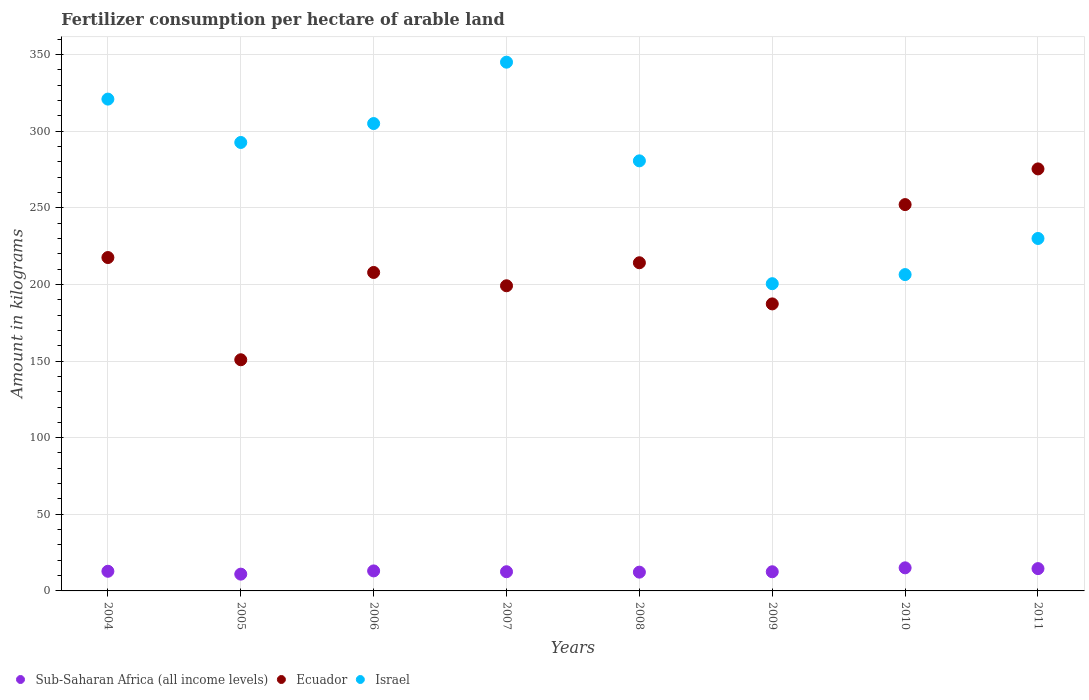How many different coloured dotlines are there?
Offer a very short reply. 3. Is the number of dotlines equal to the number of legend labels?
Provide a short and direct response. Yes. What is the amount of fertilizer consumption in Ecuador in 2004?
Your answer should be compact. 217.53. Across all years, what is the maximum amount of fertilizer consumption in Israel?
Keep it short and to the point. 345. Across all years, what is the minimum amount of fertilizer consumption in Ecuador?
Give a very brief answer. 150.83. In which year was the amount of fertilizer consumption in Ecuador maximum?
Your answer should be very brief. 2011. In which year was the amount of fertilizer consumption in Israel minimum?
Keep it short and to the point. 2009. What is the total amount of fertilizer consumption in Ecuador in the graph?
Your answer should be compact. 1704.08. What is the difference between the amount of fertilizer consumption in Israel in 2004 and that in 2008?
Keep it short and to the point. 40.29. What is the difference between the amount of fertilizer consumption in Sub-Saharan Africa (all income levels) in 2006 and the amount of fertilizer consumption in Ecuador in 2004?
Provide a short and direct response. -204.47. What is the average amount of fertilizer consumption in Sub-Saharan Africa (all income levels) per year?
Your answer should be very brief. 12.97. In the year 2008, what is the difference between the amount of fertilizer consumption in Ecuador and amount of fertilizer consumption in Sub-Saharan Africa (all income levels)?
Give a very brief answer. 201.87. What is the ratio of the amount of fertilizer consumption in Sub-Saharan Africa (all income levels) in 2006 to that in 2011?
Your answer should be compact. 0.9. What is the difference between the highest and the second highest amount of fertilizer consumption in Israel?
Make the answer very short. 24.1. What is the difference between the highest and the lowest amount of fertilizer consumption in Sub-Saharan Africa (all income levels)?
Provide a short and direct response. 4.11. In how many years, is the amount of fertilizer consumption in Ecuador greater than the average amount of fertilizer consumption in Ecuador taken over all years?
Provide a short and direct response. 4. Is the sum of the amount of fertilizer consumption in Ecuador in 2005 and 2006 greater than the maximum amount of fertilizer consumption in Sub-Saharan Africa (all income levels) across all years?
Give a very brief answer. Yes. Is the amount of fertilizer consumption in Ecuador strictly greater than the amount of fertilizer consumption in Israel over the years?
Provide a succinct answer. No. How many years are there in the graph?
Offer a very short reply. 8. Where does the legend appear in the graph?
Your answer should be compact. Bottom left. What is the title of the graph?
Keep it short and to the point. Fertilizer consumption per hectare of arable land. Does "Turks and Caicos Islands" appear as one of the legend labels in the graph?
Make the answer very short. No. What is the label or title of the X-axis?
Ensure brevity in your answer.  Years. What is the label or title of the Y-axis?
Your response must be concise. Amount in kilograms. What is the Amount in kilograms of Sub-Saharan Africa (all income levels) in 2004?
Ensure brevity in your answer.  12.82. What is the Amount in kilograms of Ecuador in 2004?
Keep it short and to the point. 217.53. What is the Amount in kilograms in Israel in 2004?
Make the answer very short. 320.9. What is the Amount in kilograms in Sub-Saharan Africa (all income levels) in 2005?
Your response must be concise. 10.95. What is the Amount in kilograms of Ecuador in 2005?
Keep it short and to the point. 150.83. What is the Amount in kilograms of Israel in 2005?
Keep it short and to the point. 292.6. What is the Amount in kilograms of Sub-Saharan Africa (all income levels) in 2006?
Provide a short and direct response. 13.06. What is the Amount in kilograms in Ecuador in 2006?
Your answer should be compact. 207.79. What is the Amount in kilograms in Israel in 2006?
Your response must be concise. 304.95. What is the Amount in kilograms of Sub-Saharan Africa (all income levels) in 2007?
Provide a short and direct response. 12.53. What is the Amount in kilograms in Ecuador in 2007?
Keep it short and to the point. 199.11. What is the Amount in kilograms in Israel in 2007?
Provide a succinct answer. 345. What is the Amount in kilograms in Sub-Saharan Africa (all income levels) in 2008?
Ensure brevity in your answer.  12.25. What is the Amount in kilograms in Ecuador in 2008?
Offer a very short reply. 214.12. What is the Amount in kilograms of Israel in 2008?
Your response must be concise. 280.61. What is the Amount in kilograms in Sub-Saharan Africa (all income levels) in 2009?
Provide a succinct answer. 12.5. What is the Amount in kilograms in Ecuador in 2009?
Your response must be concise. 187.28. What is the Amount in kilograms of Israel in 2009?
Your answer should be very brief. 200.46. What is the Amount in kilograms of Sub-Saharan Africa (all income levels) in 2010?
Your answer should be compact. 15.06. What is the Amount in kilograms in Ecuador in 2010?
Ensure brevity in your answer.  252.07. What is the Amount in kilograms in Israel in 2010?
Your answer should be very brief. 206.4. What is the Amount in kilograms of Sub-Saharan Africa (all income levels) in 2011?
Provide a short and direct response. 14.56. What is the Amount in kilograms of Ecuador in 2011?
Keep it short and to the point. 275.36. What is the Amount in kilograms of Israel in 2011?
Your answer should be very brief. 229.96. Across all years, what is the maximum Amount in kilograms of Sub-Saharan Africa (all income levels)?
Give a very brief answer. 15.06. Across all years, what is the maximum Amount in kilograms in Ecuador?
Offer a very short reply. 275.36. Across all years, what is the maximum Amount in kilograms in Israel?
Keep it short and to the point. 345. Across all years, what is the minimum Amount in kilograms of Sub-Saharan Africa (all income levels)?
Offer a terse response. 10.95. Across all years, what is the minimum Amount in kilograms in Ecuador?
Your response must be concise. 150.83. Across all years, what is the minimum Amount in kilograms in Israel?
Ensure brevity in your answer.  200.46. What is the total Amount in kilograms of Sub-Saharan Africa (all income levels) in the graph?
Your answer should be compact. 103.72. What is the total Amount in kilograms in Ecuador in the graph?
Offer a terse response. 1704.08. What is the total Amount in kilograms of Israel in the graph?
Your response must be concise. 2180.89. What is the difference between the Amount in kilograms in Sub-Saharan Africa (all income levels) in 2004 and that in 2005?
Your answer should be very brief. 1.87. What is the difference between the Amount in kilograms of Ecuador in 2004 and that in 2005?
Make the answer very short. 66.7. What is the difference between the Amount in kilograms of Israel in 2004 and that in 2005?
Offer a terse response. 28.3. What is the difference between the Amount in kilograms of Sub-Saharan Africa (all income levels) in 2004 and that in 2006?
Your answer should be compact. -0.24. What is the difference between the Amount in kilograms in Ecuador in 2004 and that in 2006?
Make the answer very short. 9.74. What is the difference between the Amount in kilograms of Israel in 2004 and that in 2006?
Your response must be concise. 15.95. What is the difference between the Amount in kilograms in Sub-Saharan Africa (all income levels) in 2004 and that in 2007?
Your answer should be very brief. 0.29. What is the difference between the Amount in kilograms in Ecuador in 2004 and that in 2007?
Ensure brevity in your answer.  18.42. What is the difference between the Amount in kilograms in Israel in 2004 and that in 2007?
Provide a short and direct response. -24.1. What is the difference between the Amount in kilograms in Sub-Saharan Africa (all income levels) in 2004 and that in 2008?
Provide a short and direct response. 0.57. What is the difference between the Amount in kilograms of Ecuador in 2004 and that in 2008?
Ensure brevity in your answer.  3.41. What is the difference between the Amount in kilograms in Israel in 2004 and that in 2008?
Provide a short and direct response. 40.29. What is the difference between the Amount in kilograms in Sub-Saharan Africa (all income levels) in 2004 and that in 2009?
Your answer should be very brief. 0.32. What is the difference between the Amount in kilograms in Ecuador in 2004 and that in 2009?
Make the answer very short. 30.25. What is the difference between the Amount in kilograms in Israel in 2004 and that in 2009?
Provide a short and direct response. 120.44. What is the difference between the Amount in kilograms in Sub-Saharan Africa (all income levels) in 2004 and that in 2010?
Make the answer very short. -2.24. What is the difference between the Amount in kilograms of Ecuador in 2004 and that in 2010?
Your answer should be very brief. -34.54. What is the difference between the Amount in kilograms in Israel in 2004 and that in 2010?
Provide a succinct answer. 114.5. What is the difference between the Amount in kilograms in Sub-Saharan Africa (all income levels) in 2004 and that in 2011?
Your response must be concise. -1.74. What is the difference between the Amount in kilograms in Ecuador in 2004 and that in 2011?
Provide a short and direct response. -57.83. What is the difference between the Amount in kilograms in Israel in 2004 and that in 2011?
Offer a very short reply. 90.94. What is the difference between the Amount in kilograms of Sub-Saharan Africa (all income levels) in 2005 and that in 2006?
Give a very brief answer. -2.11. What is the difference between the Amount in kilograms of Ecuador in 2005 and that in 2006?
Provide a short and direct response. -56.96. What is the difference between the Amount in kilograms in Israel in 2005 and that in 2006?
Offer a terse response. -12.35. What is the difference between the Amount in kilograms in Sub-Saharan Africa (all income levels) in 2005 and that in 2007?
Offer a terse response. -1.58. What is the difference between the Amount in kilograms in Ecuador in 2005 and that in 2007?
Keep it short and to the point. -48.28. What is the difference between the Amount in kilograms of Israel in 2005 and that in 2007?
Give a very brief answer. -52.39. What is the difference between the Amount in kilograms of Sub-Saharan Africa (all income levels) in 2005 and that in 2008?
Provide a succinct answer. -1.3. What is the difference between the Amount in kilograms of Ecuador in 2005 and that in 2008?
Offer a terse response. -63.29. What is the difference between the Amount in kilograms of Israel in 2005 and that in 2008?
Give a very brief answer. 11.99. What is the difference between the Amount in kilograms in Sub-Saharan Africa (all income levels) in 2005 and that in 2009?
Ensure brevity in your answer.  -1.55. What is the difference between the Amount in kilograms in Ecuador in 2005 and that in 2009?
Make the answer very short. -36.45. What is the difference between the Amount in kilograms of Israel in 2005 and that in 2009?
Your answer should be very brief. 92.14. What is the difference between the Amount in kilograms of Sub-Saharan Africa (all income levels) in 2005 and that in 2010?
Offer a very short reply. -4.11. What is the difference between the Amount in kilograms of Ecuador in 2005 and that in 2010?
Your answer should be compact. -101.24. What is the difference between the Amount in kilograms in Israel in 2005 and that in 2010?
Offer a very short reply. 86.2. What is the difference between the Amount in kilograms of Sub-Saharan Africa (all income levels) in 2005 and that in 2011?
Your answer should be very brief. -3.61. What is the difference between the Amount in kilograms in Ecuador in 2005 and that in 2011?
Ensure brevity in your answer.  -124.53. What is the difference between the Amount in kilograms in Israel in 2005 and that in 2011?
Your answer should be compact. 62.64. What is the difference between the Amount in kilograms of Sub-Saharan Africa (all income levels) in 2006 and that in 2007?
Offer a terse response. 0.53. What is the difference between the Amount in kilograms of Ecuador in 2006 and that in 2007?
Your answer should be very brief. 8.68. What is the difference between the Amount in kilograms in Israel in 2006 and that in 2007?
Offer a very short reply. -40.05. What is the difference between the Amount in kilograms in Sub-Saharan Africa (all income levels) in 2006 and that in 2008?
Offer a very short reply. 0.81. What is the difference between the Amount in kilograms of Ecuador in 2006 and that in 2008?
Your response must be concise. -6.33. What is the difference between the Amount in kilograms in Israel in 2006 and that in 2008?
Your response must be concise. 24.34. What is the difference between the Amount in kilograms in Sub-Saharan Africa (all income levels) in 2006 and that in 2009?
Keep it short and to the point. 0.56. What is the difference between the Amount in kilograms of Ecuador in 2006 and that in 2009?
Make the answer very short. 20.51. What is the difference between the Amount in kilograms of Israel in 2006 and that in 2009?
Make the answer very short. 104.49. What is the difference between the Amount in kilograms in Sub-Saharan Africa (all income levels) in 2006 and that in 2010?
Your response must be concise. -2. What is the difference between the Amount in kilograms of Ecuador in 2006 and that in 2010?
Your response must be concise. -44.28. What is the difference between the Amount in kilograms of Israel in 2006 and that in 2010?
Keep it short and to the point. 98.55. What is the difference between the Amount in kilograms of Sub-Saharan Africa (all income levels) in 2006 and that in 2011?
Make the answer very short. -1.5. What is the difference between the Amount in kilograms of Ecuador in 2006 and that in 2011?
Your answer should be very brief. -67.57. What is the difference between the Amount in kilograms in Israel in 2006 and that in 2011?
Offer a very short reply. 74.99. What is the difference between the Amount in kilograms of Sub-Saharan Africa (all income levels) in 2007 and that in 2008?
Offer a very short reply. 0.28. What is the difference between the Amount in kilograms of Ecuador in 2007 and that in 2008?
Keep it short and to the point. -15.01. What is the difference between the Amount in kilograms in Israel in 2007 and that in 2008?
Offer a terse response. 64.38. What is the difference between the Amount in kilograms of Sub-Saharan Africa (all income levels) in 2007 and that in 2009?
Your response must be concise. 0.03. What is the difference between the Amount in kilograms of Ecuador in 2007 and that in 2009?
Provide a short and direct response. 11.83. What is the difference between the Amount in kilograms in Israel in 2007 and that in 2009?
Your answer should be very brief. 144.54. What is the difference between the Amount in kilograms of Sub-Saharan Africa (all income levels) in 2007 and that in 2010?
Your answer should be compact. -2.53. What is the difference between the Amount in kilograms in Ecuador in 2007 and that in 2010?
Your answer should be compact. -52.96. What is the difference between the Amount in kilograms of Israel in 2007 and that in 2010?
Your answer should be very brief. 138.59. What is the difference between the Amount in kilograms of Sub-Saharan Africa (all income levels) in 2007 and that in 2011?
Your response must be concise. -2.03. What is the difference between the Amount in kilograms of Ecuador in 2007 and that in 2011?
Provide a succinct answer. -76.25. What is the difference between the Amount in kilograms in Israel in 2007 and that in 2011?
Provide a short and direct response. 115.03. What is the difference between the Amount in kilograms in Sub-Saharan Africa (all income levels) in 2008 and that in 2009?
Provide a short and direct response. -0.25. What is the difference between the Amount in kilograms of Ecuador in 2008 and that in 2009?
Ensure brevity in your answer.  26.84. What is the difference between the Amount in kilograms of Israel in 2008 and that in 2009?
Make the answer very short. 80.15. What is the difference between the Amount in kilograms of Sub-Saharan Africa (all income levels) in 2008 and that in 2010?
Ensure brevity in your answer.  -2.81. What is the difference between the Amount in kilograms of Ecuador in 2008 and that in 2010?
Your answer should be compact. -37.95. What is the difference between the Amount in kilograms in Israel in 2008 and that in 2010?
Ensure brevity in your answer.  74.21. What is the difference between the Amount in kilograms of Sub-Saharan Africa (all income levels) in 2008 and that in 2011?
Give a very brief answer. -2.31. What is the difference between the Amount in kilograms of Ecuador in 2008 and that in 2011?
Make the answer very short. -61.24. What is the difference between the Amount in kilograms of Israel in 2008 and that in 2011?
Your answer should be very brief. 50.65. What is the difference between the Amount in kilograms in Sub-Saharan Africa (all income levels) in 2009 and that in 2010?
Your answer should be very brief. -2.56. What is the difference between the Amount in kilograms in Ecuador in 2009 and that in 2010?
Offer a terse response. -64.79. What is the difference between the Amount in kilograms of Israel in 2009 and that in 2010?
Your answer should be very brief. -5.94. What is the difference between the Amount in kilograms of Sub-Saharan Africa (all income levels) in 2009 and that in 2011?
Make the answer very short. -2.06. What is the difference between the Amount in kilograms of Ecuador in 2009 and that in 2011?
Your response must be concise. -88.08. What is the difference between the Amount in kilograms of Israel in 2009 and that in 2011?
Give a very brief answer. -29.5. What is the difference between the Amount in kilograms of Sub-Saharan Africa (all income levels) in 2010 and that in 2011?
Your answer should be very brief. 0.5. What is the difference between the Amount in kilograms of Ecuador in 2010 and that in 2011?
Ensure brevity in your answer.  -23.28. What is the difference between the Amount in kilograms in Israel in 2010 and that in 2011?
Your response must be concise. -23.56. What is the difference between the Amount in kilograms in Sub-Saharan Africa (all income levels) in 2004 and the Amount in kilograms in Ecuador in 2005?
Make the answer very short. -138.01. What is the difference between the Amount in kilograms of Sub-Saharan Africa (all income levels) in 2004 and the Amount in kilograms of Israel in 2005?
Provide a short and direct response. -279.78. What is the difference between the Amount in kilograms in Ecuador in 2004 and the Amount in kilograms in Israel in 2005?
Provide a succinct answer. -75.08. What is the difference between the Amount in kilograms in Sub-Saharan Africa (all income levels) in 2004 and the Amount in kilograms in Ecuador in 2006?
Keep it short and to the point. -194.97. What is the difference between the Amount in kilograms in Sub-Saharan Africa (all income levels) in 2004 and the Amount in kilograms in Israel in 2006?
Provide a succinct answer. -292.13. What is the difference between the Amount in kilograms in Ecuador in 2004 and the Amount in kilograms in Israel in 2006?
Offer a very short reply. -87.42. What is the difference between the Amount in kilograms of Sub-Saharan Africa (all income levels) in 2004 and the Amount in kilograms of Ecuador in 2007?
Your answer should be very brief. -186.29. What is the difference between the Amount in kilograms of Sub-Saharan Africa (all income levels) in 2004 and the Amount in kilograms of Israel in 2007?
Provide a succinct answer. -332.18. What is the difference between the Amount in kilograms of Ecuador in 2004 and the Amount in kilograms of Israel in 2007?
Offer a terse response. -127.47. What is the difference between the Amount in kilograms of Sub-Saharan Africa (all income levels) in 2004 and the Amount in kilograms of Ecuador in 2008?
Provide a succinct answer. -201.3. What is the difference between the Amount in kilograms of Sub-Saharan Africa (all income levels) in 2004 and the Amount in kilograms of Israel in 2008?
Provide a short and direct response. -267.79. What is the difference between the Amount in kilograms of Ecuador in 2004 and the Amount in kilograms of Israel in 2008?
Give a very brief answer. -63.08. What is the difference between the Amount in kilograms in Sub-Saharan Africa (all income levels) in 2004 and the Amount in kilograms in Ecuador in 2009?
Keep it short and to the point. -174.46. What is the difference between the Amount in kilograms of Sub-Saharan Africa (all income levels) in 2004 and the Amount in kilograms of Israel in 2009?
Offer a terse response. -187.64. What is the difference between the Amount in kilograms in Ecuador in 2004 and the Amount in kilograms in Israel in 2009?
Your response must be concise. 17.07. What is the difference between the Amount in kilograms in Sub-Saharan Africa (all income levels) in 2004 and the Amount in kilograms in Ecuador in 2010?
Offer a terse response. -239.25. What is the difference between the Amount in kilograms in Sub-Saharan Africa (all income levels) in 2004 and the Amount in kilograms in Israel in 2010?
Your answer should be very brief. -193.58. What is the difference between the Amount in kilograms in Ecuador in 2004 and the Amount in kilograms in Israel in 2010?
Give a very brief answer. 11.13. What is the difference between the Amount in kilograms of Sub-Saharan Africa (all income levels) in 2004 and the Amount in kilograms of Ecuador in 2011?
Provide a short and direct response. -262.53. What is the difference between the Amount in kilograms in Sub-Saharan Africa (all income levels) in 2004 and the Amount in kilograms in Israel in 2011?
Your response must be concise. -217.14. What is the difference between the Amount in kilograms in Ecuador in 2004 and the Amount in kilograms in Israel in 2011?
Offer a terse response. -12.43. What is the difference between the Amount in kilograms of Sub-Saharan Africa (all income levels) in 2005 and the Amount in kilograms of Ecuador in 2006?
Keep it short and to the point. -196.84. What is the difference between the Amount in kilograms in Sub-Saharan Africa (all income levels) in 2005 and the Amount in kilograms in Israel in 2006?
Your response must be concise. -294. What is the difference between the Amount in kilograms of Ecuador in 2005 and the Amount in kilograms of Israel in 2006?
Make the answer very short. -154.12. What is the difference between the Amount in kilograms in Sub-Saharan Africa (all income levels) in 2005 and the Amount in kilograms in Ecuador in 2007?
Make the answer very short. -188.16. What is the difference between the Amount in kilograms in Sub-Saharan Africa (all income levels) in 2005 and the Amount in kilograms in Israel in 2007?
Make the answer very short. -334.05. What is the difference between the Amount in kilograms in Ecuador in 2005 and the Amount in kilograms in Israel in 2007?
Provide a succinct answer. -194.17. What is the difference between the Amount in kilograms in Sub-Saharan Africa (all income levels) in 2005 and the Amount in kilograms in Ecuador in 2008?
Make the answer very short. -203.17. What is the difference between the Amount in kilograms of Sub-Saharan Africa (all income levels) in 2005 and the Amount in kilograms of Israel in 2008?
Make the answer very short. -269.66. What is the difference between the Amount in kilograms in Ecuador in 2005 and the Amount in kilograms in Israel in 2008?
Offer a very short reply. -129.78. What is the difference between the Amount in kilograms of Sub-Saharan Africa (all income levels) in 2005 and the Amount in kilograms of Ecuador in 2009?
Offer a very short reply. -176.33. What is the difference between the Amount in kilograms in Sub-Saharan Africa (all income levels) in 2005 and the Amount in kilograms in Israel in 2009?
Offer a terse response. -189.51. What is the difference between the Amount in kilograms of Ecuador in 2005 and the Amount in kilograms of Israel in 2009?
Provide a short and direct response. -49.63. What is the difference between the Amount in kilograms of Sub-Saharan Africa (all income levels) in 2005 and the Amount in kilograms of Ecuador in 2010?
Offer a very short reply. -241.12. What is the difference between the Amount in kilograms in Sub-Saharan Africa (all income levels) in 2005 and the Amount in kilograms in Israel in 2010?
Keep it short and to the point. -195.45. What is the difference between the Amount in kilograms in Ecuador in 2005 and the Amount in kilograms in Israel in 2010?
Provide a short and direct response. -55.57. What is the difference between the Amount in kilograms in Sub-Saharan Africa (all income levels) in 2005 and the Amount in kilograms in Ecuador in 2011?
Offer a very short reply. -264.41. What is the difference between the Amount in kilograms in Sub-Saharan Africa (all income levels) in 2005 and the Amount in kilograms in Israel in 2011?
Make the answer very short. -219.01. What is the difference between the Amount in kilograms in Ecuador in 2005 and the Amount in kilograms in Israel in 2011?
Make the answer very short. -79.13. What is the difference between the Amount in kilograms in Sub-Saharan Africa (all income levels) in 2006 and the Amount in kilograms in Ecuador in 2007?
Your answer should be compact. -186.05. What is the difference between the Amount in kilograms in Sub-Saharan Africa (all income levels) in 2006 and the Amount in kilograms in Israel in 2007?
Keep it short and to the point. -331.94. What is the difference between the Amount in kilograms of Ecuador in 2006 and the Amount in kilograms of Israel in 2007?
Ensure brevity in your answer.  -137.21. What is the difference between the Amount in kilograms in Sub-Saharan Africa (all income levels) in 2006 and the Amount in kilograms in Ecuador in 2008?
Your answer should be very brief. -201.06. What is the difference between the Amount in kilograms of Sub-Saharan Africa (all income levels) in 2006 and the Amount in kilograms of Israel in 2008?
Offer a very short reply. -267.56. What is the difference between the Amount in kilograms of Ecuador in 2006 and the Amount in kilograms of Israel in 2008?
Give a very brief answer. -72.82. What is the difference between the Amount in kilograms in Sub-Saharan Africa (all income levels) in 2006 and the Amount in kilograms in Ecuador in 2009?
Your answer should be compact. -174.22. What is the difference between the Amount in kilograms of Sub-Saharan Africa (all income levels) in 2006 and the Amount in kilograms of Israel in 2009?
Give a very brief answer. -187.4. What is the difference between the Amount in kilograms of Ecuador in 2006 and the Amount in kilograms of Israel in 2009?
Provide a short and direct response. 7.33. What is the difference between the Amount in kilograms in Sub-Saharan Africa (all income levels) in 2006 and the Amount in kilograms in Ecuador in 2010?
Ensure brevity in your answer.  -239.01. What is the difference between the Amount in kilograms in Sub-Saharan Africa (all income levels) in 2006 and the Amount in kilograms in Israel in 2010?
Your answer should be very brief. -193.35. What is the difference between the Amount in kilograms of Ecuador in 2006 and the Amount in kilograms of Israel in 2010?
Your answer should be compact. 1.39. What is the difference between the Amount in kilograms in Sub-Saharan Africa (all income levels) in 2006 and the Amount in kilograms in Ecuador in 2011?
Provide a short and direct response. -262.3. What is the difference between the Amount in kilograms of Sub-Saharan Africa (all income levels) in 2006 and the Amount in kilograms of Israel in 2011?
Your response must be concise. -216.91. What is the difference between the Amount in kilograms of Ecuador in 2006 and the Amount in kilograms of Israel in 2011?
Offer a very short reply. -22.17. What is the difference between the Amount in kilograms in Sub-Saharan Africa (all income levels) in 2007 and the Amount in kilograms in Ecuador in 2008?
Make the answer very short. -201.59. What is the difference between the Amount in kilograms in Sub-Saharan Africa (all income levels) in 2007 and the Amount in kilograms in Israel in 2008?
Provide a short and direct response. -268.09. What is the difference between the Amount in kilograms in Ecuador in 2007 and the Amount in kilograms in Israel in 2008?
Give a very brief answer. -81.51. What is the difference between the Amount in kilograms of Sub-Saharan Africa (all income levels) in 2007 and the Amount in kilograms of Ecuador in 2009?
Your answer should be very brief. -174.75. What is the difference between the Amount in kilograms in Sub-Saharan Africa (all income levels) in 2007 and the Amount in kilograms in Israel in 2009?
Offer a very short reply. -187.93. What is the difference between the Amount in kilograms in Ecuador in 2007 and the Amount in kilograms in Israel in 2009?
Make the answer very short. -1.35. What is the difference between the Amount in kilograms in Sub-Saharan Africa (all income levels) in 2007 and the Amount in kilograms in Ecuador in 2010?
Provide a succinct answer. -239.54. What is the difference between the Amount in kilograms of Sub-Saharan Africa (all income levels) in 2007 and the Amount in kilograms of Israel in 2010?
Offer a terse response. -193.88. What is the difference between the Amount in kilograms of Ecuador in 2007 and the Amount in kilograms of Israel in 2010?
Ensure brevity in your answer.  -7.3. What is the difference between the Amount in kilograms in Sub-Saharan Africa (all income levels) in 2007 and the Amount in kilograms in Ecuador in 2011?
Give a very brief answer. -262.83. What is the difference between the Amount in kilograms in Sub-Saharan Africa (all income levels) in 2007 and the Amount in kilograms in Israel in 2011?
Keep it short and to the point. -217.43. What is the difference between the Amount in kilograms in Ecuador in 2007 and the Amount in kilograms in Israel in 2011?
Your answer should be very brief. -30.86. What is the difference between the Amount in kilograms of Sub-Saharan Africa (all income levels) in 2008 and the Amount in kilograms of Ecuador in 2009?
Offer a very short reply. -175.03. What is the difference between the Amount in kilograms of Sub-Saharan Africa (all income levels) in 2008 and the Amount in kilograms of Israel in 2009?
Provide a succinct answer. -188.21. What is the difference between the Amount in kilograms of Ecuador in 2008 and the Amount in kilograms of Israel in 2009?
Your answer should be very brief. 13.66. What is the difference between the Amount in kilograms in Sub-Saharan Africa (all income levels) in 2008 and the Amount in kilograms in Ecuador in 2010?
Keep it short and to the point. -239.82. What is the difference between the Amount in kilograms of Sub-Saharan Africa (all income levels) in 2008 and the Amount in kilograms of Israel in 2010?
Offer a very short reply. -194.16. What is the difference between the Amount in kilograms in Ecuador in 2008 and the Amount in kilograms in Israel in 2010?
Your answer should be compact. 7.72. What is the difference between the Amount in kilograms in Sub-Saharan Africa (all income levels) in 2008 and the Amount in kilograms in Ecuador in 2011?
Ensure brevity in your answer.  -263.11. What is the difference between the Amount in kilograms in Sub-Saharan Africa (all income levels) in 2008 and the Amount in kilograms in Israel in 2011?
Provide a short and direct response. -217.72. What is the difference between the Amount in kilograms of Ecuador in 2008 and the Amount in kilograms of Israel in 2011?
Provide a succinct answer. -15.84. What is the difference between the Amount in kilograms in Sub-Saharan Africa (all income levels) in 2009 and the Amount in kilograms in Ecuador in 2010?
Provide a succinct answer. -239.57. What is the difference between the Amount in kilograms of Sub-Saharan Africa (all income levels) in 2009 and the Amount in kilograms of Israel in 2010?
Provide a succinct answer. -193.9. What is the difference between the Amount in kilograms of Ecuador in 2009 and the Amount in kilograms of Israel in 2010?
Make the answer very short. -19.12. What is the difference between the Amount in kilograms of Sub-Saharan Africa (all income levels) in 2009 and the Amount in kilograms of Ecuador in 2011?
Keep it short and to the point. -262.85. What is the difference between the Amount in kilograms in Sub-Saharan Africa (all income levels) in 2009 and the Amount in kilograms in Israel in 2011?
Your answer should be compact. -217.46. What is the difference between the Amount in kilograms in Ecuador in 2009 and the Amount in kilograms in Israel in 2011?
Provide a short and direct response. -42.68. What is the difference between the Amount in kilograms of Sub-Saharan Africa (all income levels) in 2010 and the Amount in kilograms of Ecuador in 2011?
Ensure brevity in your answer.  -260.29. What is the difference between the Amount in kilograms of Sub-Saharan Africa (all income levels) in 2010 and the Amount in kilograms of Israel in 2011?
Provide a succinct answer. -214.9. What is the difference between the Amount in kilograms of Ecuador in 2010 and the Amount in kilograms of Israel in 2011?
Keep it short and to the point. 22.11. What is the average Amount in kilograms of Sub-Saharan Africa (all income levels) per year?
Offer a terse response. 12.96. What is the average Amount in kilograms in Ecuador per year?
Your answer should be compact. 213.01. What is the average Amount in kilograms of Israel per year?
Provide a short and direct response. 272.61. In the year 2004, what is the difference between the Amount in kilograms in Sub-Saharan Africa (all income levels) and Amount in kilograms in Ecuador?
Your answer should be very brief. -204.71. In the year 2004, what is the difference between the Amount in kilograms of Sub-Saharan Africa (all income levels) and Amount in kilograms of Israel?
Your response must be concise. -308.08. In the year 2004, what is the difference between the Amount in kilograms of Ecuador and Amount in kilograms of Israel?
Offer a terse response. -103.37. In the year 2005, what is the difference between the Amount in kilograms in Sub-Saharan Africa (all income levels) and Amount in kilograms in Ecuador?
Give a very brief answer. -139.88. In the year 2005, what is the difference between the Amount in kilograms of Sub-Saharan Africa (all income levels) and Amount in kilograms of Israel?
Keep it short and to the point. -281.66. In the year 2005, what is the difference between the Amount in kilograms in Ecuador and Amount in kilograms in Israel?
Your response must be concise. -141.78. In the year 2006, what is the difference between the Amount in kilograms in Sub-Saharan Africa (all income levels) and Amount in kilograms in Ecuador?
Your answer should be compact. -194.73. In the year 2006, what is the difference between the Amount in kilograms of Sub-Saharan Africa (all income levels) and Amount in kilograms of Israel?
Keep it short and to the point. -291.89. In the year 2006, what is the difference between the Amount in kilograms of Ecuador and Amount in kilograms of Israel?
Your answer should be very brief. -97.16. In the year 2007, what is the difference between the Amount in kilograms of Sub-Saharan Africa (all income levels) and Amount in kilograms of Ecuador?
Your answer should be compact. -186.58. In the year 2007, what is the difference between the Amount in kilograms of Sub-Saharan Africa (all income levels) and Amount in kilograms of Israel?
Ensure brevity in your answer.  -332.47. In the year 2007, what is the difference between the Amount in kilograms of Ecuador and Amount in kilograms of Israel?
Provide a short and direct response. -145.89. In the year 2008, what is the difference between the Amount in kilograms of Sub-Saharan Africa (all income levels) and Amount in kilograms of Ecuador?
Make the answer very short. -201.87. In the year 2008, what is the difference between the Amount in kilograms in Sub-Saharan Africa (all income levels) and Amount in kilograms in Israel?
Keep it short and to the point. -268.37. In the year 2008, what is the difference between the Amount in kilograms of Ecuador and Amount in kilograms of Israel?
Your answer should be very brief. -66.49. In the year 2009, what is the difference between the Amount in kilograms in Sub-Saharan Africa (all income levels) and Amount in kilograms in Ecuador?
Your response must be concise. -174.78. In the year 2009, what is the difference between the Amount in kilograms in Sub-Saharan Africa (all income levels) and Amount in kilograms in Israel?
Give a very brief answer. -187.96. In the year 2009, what is the difference between the Amount in kilograms of Ecuador and Amount in kilograms of Israel?
Your answer should be very brief. -13.18. In the year 2010, what is the difference between the Amount in kilograms in Sub-Saharan Africa (all income levels) and Amount in kilograms in Ecuador?
Your answer should be compact. -237.01. In the year 2010, what is the difference between the Amount in kilograms of Sub-Saharan Africa (all income levels) and Amount in kilograms of Israel?
Offer a very short reply. -191.34. In the year 2010, what is the difference between the Amount in kilograms in Ecuador and Amount in kilograms in Israel?
Your answer should be compact. 45.67. In the year 2011, what is the difference between the Amount in kilograms in Sub-Saharan Africa (all income levels) and Amount in kilograms in Ecuador?
Ensure brevity in your answer.  -260.8. In the year 2011, what is the difference between the Amount in kilograms of Sub-Saharan Africa (all income levels) and Amount in kilograms of Israel?
Provide a succinct answer. -215.41. In the year 2011, what is the difference between the Amount in kilograms in Ecuador and Amount in kilograms in Israel?
Provide a succinct answer. 45.39. What is the ratio of the Amount in kilograms of Sub-Saharan Africa (all income levels) in 2004 to that in 2005?
Your answer should be very brief. 1.17. What is the ratio of the Amount in kilograms of Ecuador in 2004 to that in 2005?
Keep it short and to the point. 1.44. What is the ratio of the Amount in kilograms of Israel in 2004 to that in 2005?
Offer a terse response. 1.1. What is the ratio of the Amount in kilograms of Sub-Saharan Africa (all income levels) in 2004 to that in 2006?
Your response must be concise. 0.98. What is the ratio of the Amount in kilograms of Ecuador in 2004 to that in 2006?
Provide a succinct answer. 1.05. What is the ratio of the Amount in kilograms in Israel in 2004 to that in 2006?
Make the answer very short. 1.05. What is the ratio of the Amount in kilograms of Sub-Saharan Africa (all income levels) in 2004 to that in 2007?
Your response must be concise. 1.02. What is the ratio of the Amount in kilograms in Ecuador in 2004 to that in 2007?
Give a very brief answer. 1.09. What is the ratio of the Amount in kilograms of Israel in 2004 to that in 2007?
Your response must be concise. 0.93. What is the ratio of the Amount in kilograms in Sub-Saharan Africa (all income levels) in 2004 to that in 2008?
Make the answer very short. 1.05. What is the ratio of the Amount in kilograms in Ecuador in 2004 to that in 2008?
Offer a terse response. 1.02. What is the ratio of the Amount in kilograms in Israel in 2004 to that in 2008?
Your answer should be very brief. 1.14. What is the ratio of the Amount in kilograms of Sub-Saharan Africa (all income levels) in 2004 to that in 2009?
Your answer should be very brief. 1.03. What is the ratio of the Amount in kilograms in Ecuador in 2004 to that in 2009?
Your answer should be compact. 1.16. What is the ratio of the Amount in kilograms in Israel in 2004 to that in 2009?
Your answer should be very brief. 1.6. What is the ratio of the Amount in kilograms of Sub-Saharan Africa (all income levels) in 2004 to that in 2010?
Your response must be concise. 0.85. What is the ratio of the Amount in kilograms of Ecuador in 2004 to that in 2010?
Make the answer very short. 0.86. What is the ratio of the Amount in kilograms of Israel in 2004 to that in 2010?
Give a very brief answer. 1.55. What is the ratio of the Amount in kilograms of Sub-Saharan Africa (all income levels) in 2004 to that in 2011?
Give a very brief answer. 0.88. What is the ratio of the Amount in kilograms of Ecuador in 2004 to that in 2011?
Make the answer very short. 0.79. What is the ratio of the Amount in kilograms in Israel in 2004 to that in 2011?
Your answer should be very brief. 1.4. What is the ratio of the Amount in kilograms of Sub-Saharan Africa (all income levels) in 2005 to that in 2006?
Ensure brevity in your answer.  0.84. What is the ratio of the Amount in kilograms in Ecuador in 2005 to that in 2006?
Your answer should be compact. 0.73. What is the ratio of the Amount in kilograms in Israel in 2005 to that in 2006?
Your answer should be compact. 0.96. What is the ratio of the Amount in kilograms in Sub-Saharan Africa (all income levels) in 2005 to that in 2007?
Your answer should be compact. 0.87. What is the ratio of the Amount in kilograms in Ecuador in 2005 to that in 2007?
Your response must be concise. 0.76. What is the ratio of the Amount in kilograms of Israel in 2005 to that in 2007?
Provide a short and direct response. 0.85. What is the ratio of the Amount in kilograms in Sub-Saharan Africa (all income levels) in 2005 to that in 2008?
Make the answer very short. 0.89. What is the ratio of the Amount in kilograms of Ecuador in 2005 to that in 2008?
Ensure brevity in your answer.  0.7. What is the ratio of the Amount in kilograms in Israel in 2005 to that in 2008?
Your response must be concise. 1.04. What is the ratio of the Amount in kilograms of Sub-Saharan Africa (all income levels) in 2005 to that in 2009?
Ensure brevity in your answer.  0.88. What is the ratio of the Amount in kilograms of Ecuador in 2005 to that in 2009?
Your answer should be very brief. 0.81. What is the ratio of the Amount in kilograms of Israel in 2005 to that in 2009?
Give a very brief answer. 1.46. What is the ratio of the Amount in kilograms in Sub-Saharan Africa (all income levels) in 2005 to that in 2010?
Provide a succinct answer. 0.73. What is the ratio of the Amount in kilograms in Ecuador in 2005 to that in 2010?
Your answer should be compact. 0.6. What is the ratio of the Amount in kilograms in Israel in 2005 to that in 2010?
Your answer should be compact. 1.42. What is the ratio of the Amount in kilograms of Sub-Saharan Africa (all income levels) in 2005 to that in 2011?
Give a very brief answer. 0.75. What is the ratio of the Amount in kilograms of Ecuador in 2005 to that in 2011?
Your response must be concise. 0.55. What is the ratio of the Amount in kilograms in Israel in 2005 to that in 2011?
Your response must be concise. 1.27. What is the ratio of the Amount in kilograms in Sub-Saharan Africa (all income levels) in 2006 to that in 2007?
Your answer should be compact. 1.04. What is the ratio of the Amount in kilograms in Ecuador in 2006 to that in 2007?
Provide a succinct answer. 1.04. What is the ratio of the Amount in kilograms in Israel in 2006 to that in 2007?
Keep it short and to the point. 0.88. What is the ratio of the Amount in kilograms in Sub-Saharan Africa (all income levels) in 2006 to that in 2008?
Offer a very short reply. 1.07. What is the ratio of the Amount in kilograms in Ecuador in 2006 to that in 2008?
Your answer should be compact. 0.97. What is the ratio of the Amount in kilograms in Israel in 2006 to that in 2008?
Provide a succinct answer. 1.09. What is the ratio of the Amount in kilograms in Sub-Saharan Africa (all income levels) in 2006 to that in 2009?
Make the answer very short. 1.04. What is the ratio of the Amount in kilograms of Ecuador in 2006 to that in 2009?
Ensure brevity in your answer.  1.11. What is the ratio of the Amount in kilograms of Israel in 2006 to that in 2009?
Your response must be concise. 1.52. What is the ratio of the Amount in kilograms in Sub-Saharan Africa (all income levels) in 2006 to that in 2010?
Keep it short and to the point. 0.87. What is the ratio of the Amount in kilograms in Ecuador in 2006 to that in 2010?
Your response must be concise. 0.82. What is the ratio of the Amount in kilograms in Israel in 2006 to that in 2010?
Offer a terse response. 1.48. What is the ratio of the Amount in kilograms of Sub-Saharan Africa (all income levels) in 2006 to that in 2011?
Offer a terse response. 0.9. What is the ratio of the Amount in kilograms in Ecuador in 2006 to that in 2011?
Offer a very short reply. 0.75. What is the ratio of the Amount in kilograms of Israel in 2006 to that in 2011?
Make the answer very short. 1.33. What is the ratio of the Amount in kilograms in Sub-Saharan Africa (all income levels) in 2007 to that in 2008?
Offer a terse response. 1.02. What is the ratio of the Amount in kilograms in Ecuador in 2007 to that in 2008?
Your answer should be very brief. 0.93. What is the ratio of the Amount in kilograms of Israel in 2007 to that in 2008?
Offer a terse response. 1.23. What is the ratio of the Amount in kilograms of Sub-Saharan Africa (all income levels) in 2007 to that in 2009?
Keep it short and to the point. 1. What is the ratio of the Amount in kilograms in Ecuador in 2007 to that in 2009?
Your answer should be compact. 1.06. What is the ratio of the Amount in kilograms in Israel in 2007 to that in 2009?
Your response must be concise. 1.72. What is the ratio of the Amount in kilograms of Sub-Saharan Africa (all income levels) in 2007 to that in 2010?
Provide a succinct answer. 0.83. What is the ratio of the Amount in kilograms in Ecuador in 2007 to that in 2010?
Keep it short and to the point. 0.79. What is the ratio of the Amount in kilograms of Israel in 2007 to that in 2010?
Your answer should be compact. 1.67. What is the ratio of the Amount in kilograms in Sub-Saharan Africa (all income levels) in 2007 to that in 2011?
Your response must be concise. 0.86. What is the ratio of the Amount in kilograms of Ecuador in 2007 to that in 2011?
Offer a terse response. 0.72. What is the ratio of the Amount in kilograms of Israel in 2007 to that in 2011?
Your answer should be compact. 1.5. What is the ratio of the Amount in kilograms in Sub-Saharan Africa (all income levels) in 2008 to that in 2009?
Offer a terse response. 0.98. What is the ratio of the Amount in kilograms in Ecuador in 2008 to that in 2009?
Offer a very short reply. 1.14. What is the ratio of the Amount in kilograms of Israel in 2008 to that in 2009?
Give a very brief answer. 1.4. What is the ratio of the Amount in kilograms in Sub-Saharan Africa (all income levels) in 2008 to that in 2010?
Your response must be concise. 0.81. What is the ratio of the Amount in kilograms in Ecuador in 2008 to that in 2010?
Offer a very short reply. 0.85. What is the ratio of the Amount in kilograms of Israel in 2008 to that in 2010?
Offer a terse response. 1.36. What is the ratio of the Amount in kilograms in Sub-Saharan Africa (all income levels) in 2008 to that in 2011?
Provide a short and direct response. 0.84. What is the ratio of the Amount in kilograms in Ecuador in 2008 to that in 2011?
Make the answer very short. 0.78. What is the ratio of the Amount in kilograms in Israel in 2008 to that in 2011?
Your answer should be very brief. 1.22. What is the ratio of the Amount in kilograms in Sub-Saharan Africa (all income levels) in 2009 to that in 2010?
Your answer should be compact. 0.83. What is the ratio of the Amount in kilograms in Ecuador in 2009 to that in 2010?
Make the answer very short. 0.74. What is the ratio of the Amount in kilograms of Israel in 2009 to that in 2010?
Keep it short and to the point. 0.97. What is the ratio of the Amount in kilograms of Sub-Saharan Africa (all income levels) in 2009 to that in 2011?
Ensure brevity in your answer.  0.86. What is the ratio of the Amount in kilograms in Ecuador in 2009 to that in 2011?
Offer a very short reply. 0.68. What is the ratio of the Amount in kilograms in Israel in 2009 to that in 2011?
Make the answer very short. 0.87. What is the ratio of the Amount in kilograms of Sub-Saharan Africa (all income levels) in 2010 to that in 2011?
Give a very brief answer. 1.03. What is the ratio of the Amount in kilograms in Ecuador in 2010 to that in 2011?
Provide a short and direct response. 0.92. What is the ratio of the Amount in kilograms of Israel in 2010 to that in 2011?
Ensure brevity in your answer.  0.9. What is the difference between the highest and the second highest Amount in kilograms in Sub-Saharan Africa (all income levels)?
Your answer should be compact. 0.5. What is the difference between the highest and the second highest Amount in kilograms in Ecuador?
Keep it short and to the point. 23.28. What is the difference between the highest and the second highest Amount in kilograms in Israel?
Keep it short and to the point. 24.1. What is the difference between the highest and the lowest Amount in kilograms in Sub-Saharan Africa (all income levels)?
Offer a very short reply. 4.11. What is the difference between the highest and the lowest Amount in kilograms in Ecuador?
Your answer should be very brief. 124.53. What is the difference between the highest and the lowest Amount in kilograms in Israel?
Provide a succinct answer. 144.54. 